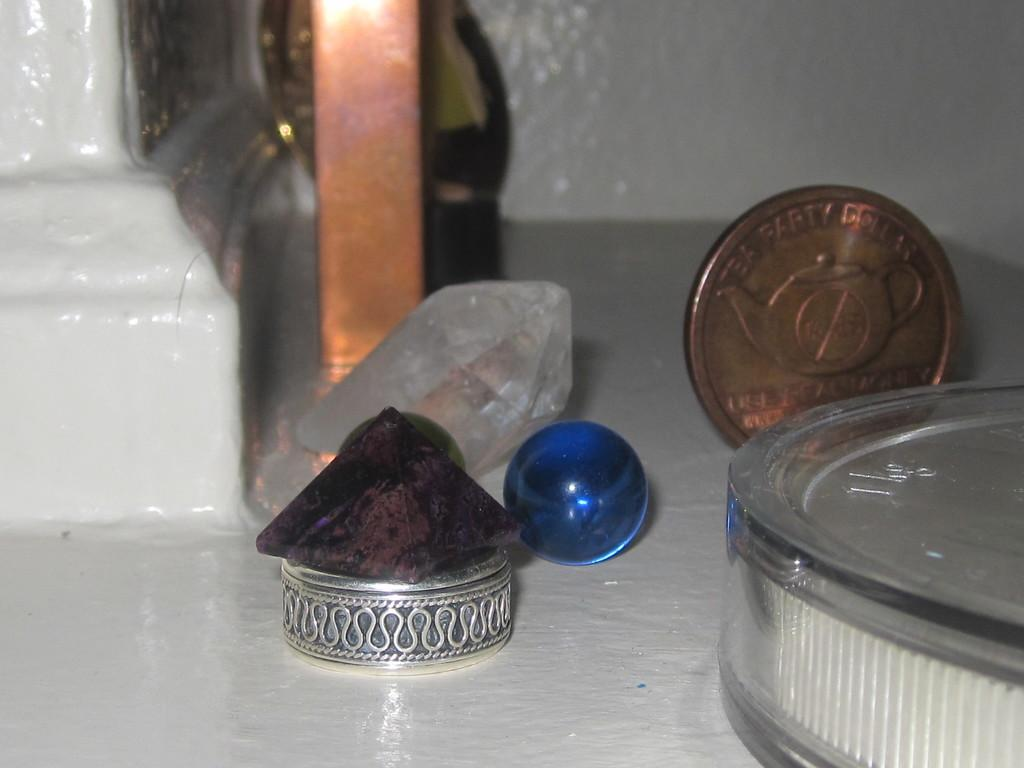<image>
Offer a succinct explanation of the picture presented. A large 1KG coin in a plastic case next to a blue glass ball. 